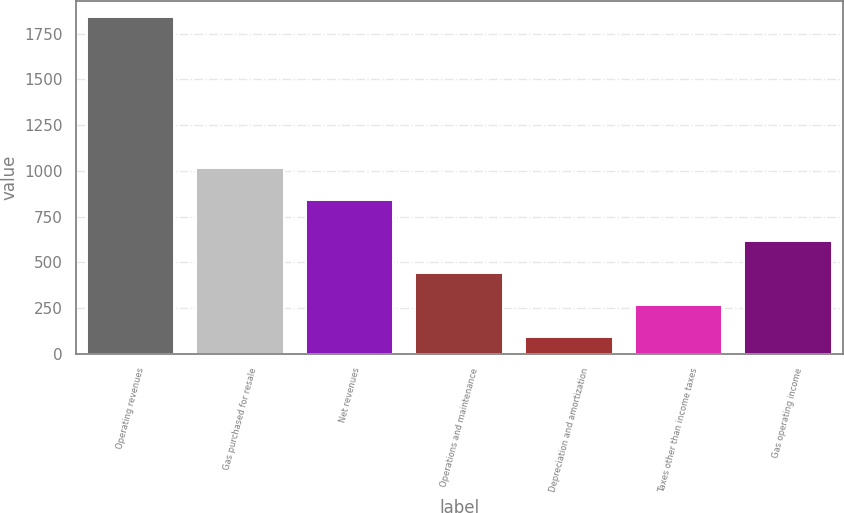<chart> <loc_0><loc_0><loc_500><loc_500><bar_chart><fcel>Operating revenues<fcel>Gas purchased for resale<fcel>Net revenues<fcel>Operations and maintenance<fcel>Depreciation and amortization<fcel>Taxes other than income taxes<fcel>Gas operating income<nl><fcel>1839<fcel>1014.9<fcel>840<fcel>439.8<fcel>90<fcel>264.9<fcel>614.7<nl></chart> 